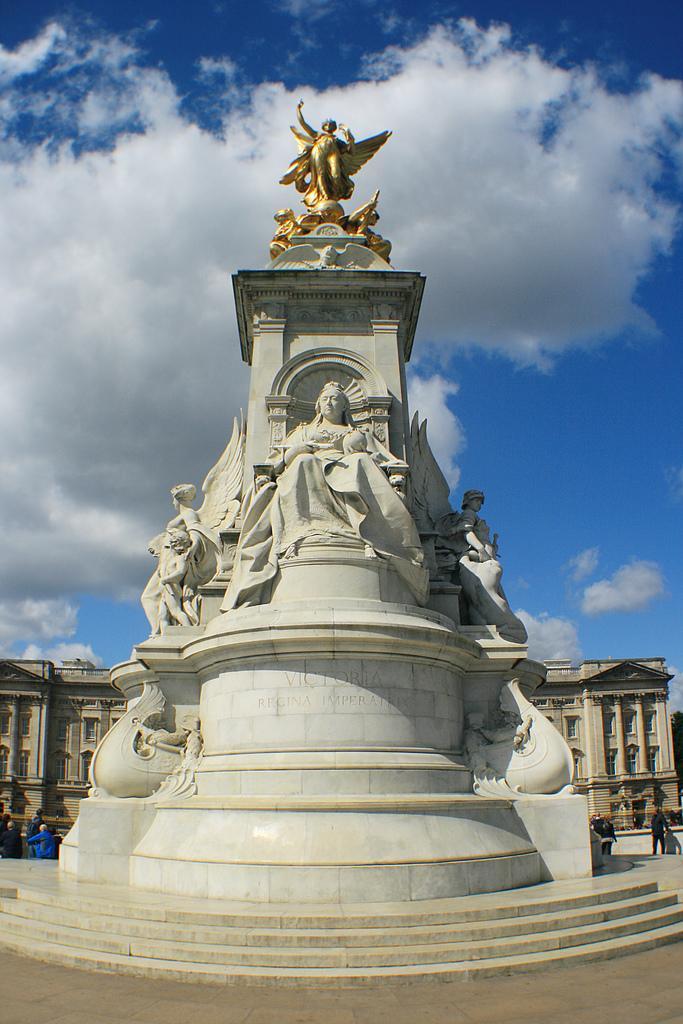Please provide a concise description of this image. This is an outside view. Here I can see few statues on a pillar. At the bottom, I can see the ground. In the background there is a building and I can see few people on the ground. At the top of the image I can see the sky and clouds. 